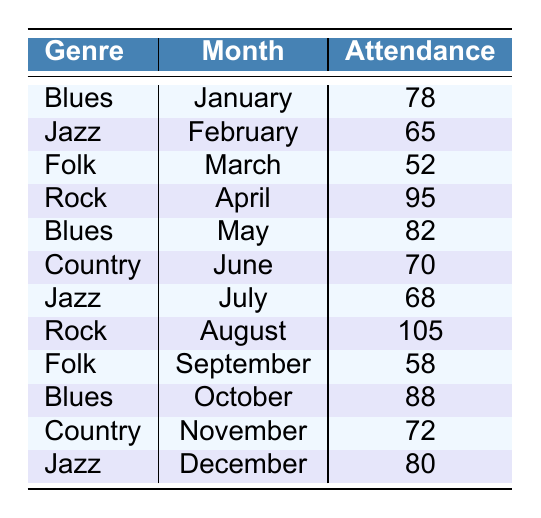What genre had the highest attendance in August? Looking at the table, the genre performed in August is Rock with an attendance of 105.
Answer: Rock How many performances did the Blues genre have in total? The Blues genre had performances in January, May, and October. Adding their attendances gives (78 + 82 + 88) = 248.
Answer: 248 Which month had the lowest attendance and what was the genre? By reviewing the table, March has the lowest attendance at 52, and the genre was Folk.
Answer: March, Folk What was the average attendance for Jazz performances? Jazz performances were in February, July, and December with attendances of 65, 68, and 80. Adding these gives (65 + 68 + 80) = 213. Dividing by the number of performances, 213/3 = 71.
Answer: 71 Did Folk performances ever exceed 60 attendees? The attendance for Folk in March was 52 and in September was 58, both below 60. Hence, Folk performances did not exceed 60.
Answer: No How many more attendees did Rock have in April compared to Folk in March? Rock had 95 attendees in April, while Folk had 52 in March. The difference of 95 - 52 = 43 means Rock had 43 more attendees.
Answer: 43 Which genre had consistent performances with attendance above 70? Blues had 78, 82, and 88; Country had 70 and 72; Jazz had 80. Only Blues and Jazz had consistent attendance above 70.
Answer: Blues, Jazz What is the total attendance across all genres for the months of June to August? The attendances for June, July, and August are Country (70), Jazz (68), and Rock (105). Adding them gives (70 + 68 + 105) = 243.
Answer: 243 How many total performances were there for Folk and how does it compare to Rock? Folk had 2 performances (52 in March and 58 in September), while Rock had 2 performances (95 in April and 105 in August). Folk and Rock both had two performances each.
Answer: Equal Was the attendance for the last performance of the year, Jazz in December, greater than the attendance for Country in June? The Jazz attendance in December was 80, and Country's attendance in June was 70. Since 80 > 70, Jazz had greater attendance.
Answer: Yes 